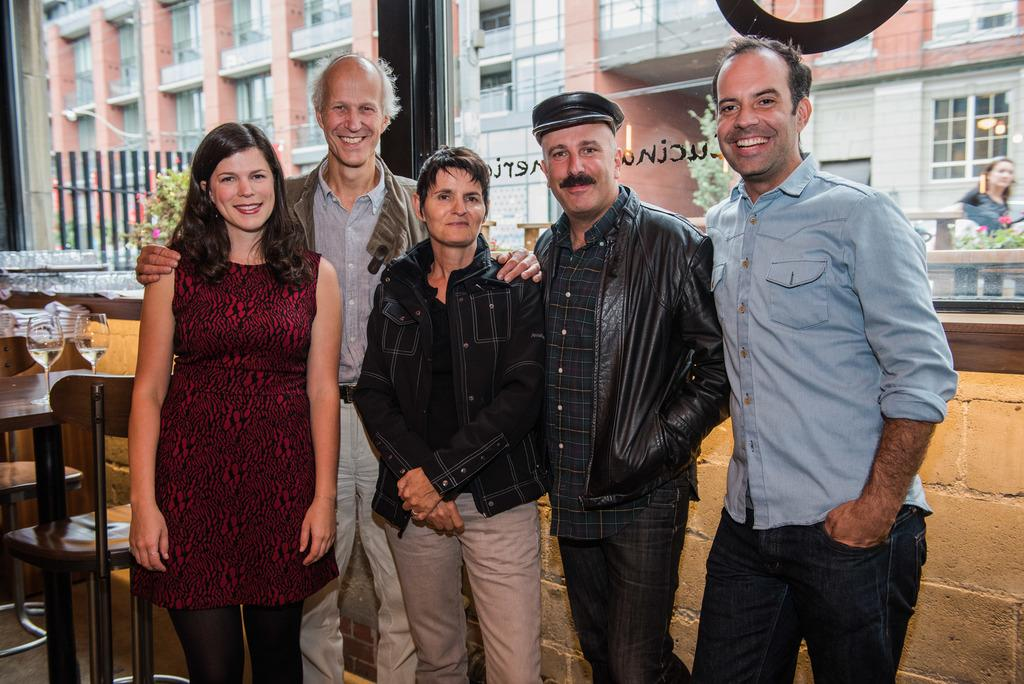How many individuals are present in the image? There are five people in the image. Can you describe the gender distribution among the people? Three of them are men, and two of them are women. What is the facial expression of the people in the image? All of them are smiling. What can be seen in the background of the image? There is a building in the background of the image. Where is the seashore located in the image? There is no seashore present in the image. What type of joke is being told by the men in the image? There is no joke being told in the image; the people are simply smiling. 